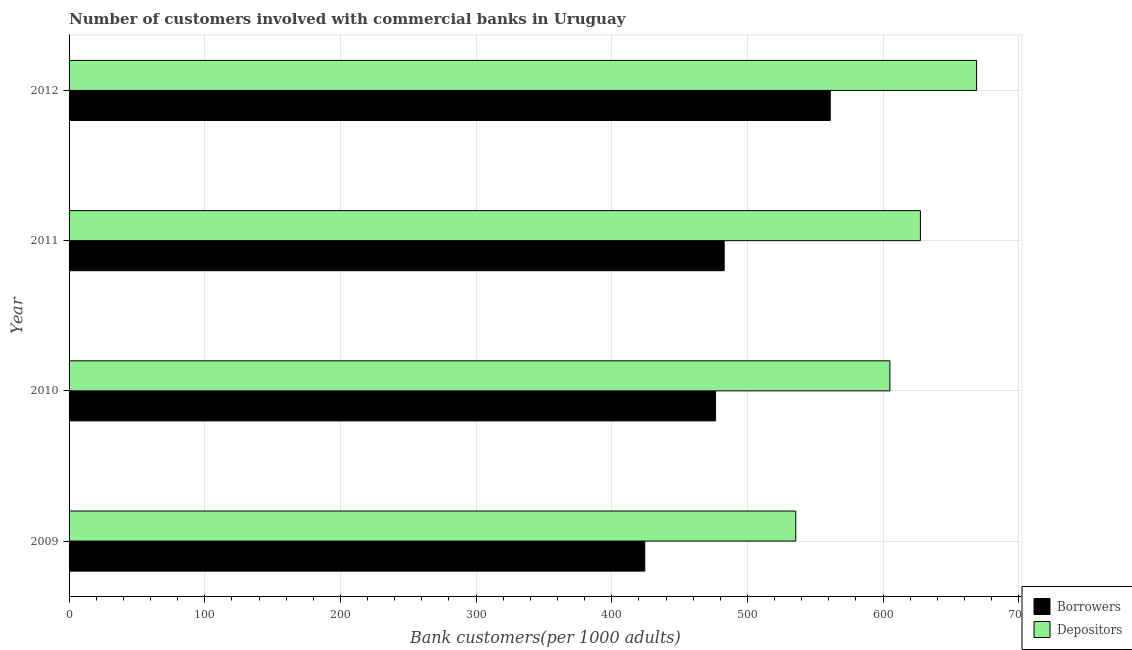How many different coloured bars are there?
Give a very brief answer. 2. Are the number of bars per tick equal to the number of legend labels?
Provide a short and direct response. Yes. What is the number of depositors in 2012?
Provide a succinct answer. 668.96. Across all years, what is the maximum number of borrowers?
Ensure brevity in your answer.  561.08. Across all years, what is the minimum number of depositors?
Offer a terse response. 535.65. What is the total number of depositors in the graph?
Make the answer very short. 2437.19. What is the difference between the number of depositors in 2009 and that in 2010?
Ensure brevity in your answer.  -69.39. What is the difference between the number of borrowers in 2010 and the number of depositors in 2011?
Make the answer very short. -150.98. What is the average number of depositors per year?
Give a very brief answer. 609.3. In the year 2011, what is the difference between the number of depositors and number of borrowers?
Offer a very short reply. 144.65. In how many years, is the number of borrowers greater than 220 ?
Provide a succinct answer. 4. What is the ratio of the number of borrowers in 2009 to that in 2011?
Your response must be concise. 0.88. Is the number of borrowers in 2011 less than that in 2012?
Give a very brief answer. Yes. What is the difference between the highest and the second highest number of depositors?
Offer a terse response. 41.43. What is the difference between the highest and the lowest number of depositors?
Your answer should be very brief. 133.31. In how many years, is the number of borrowers greater than the average number of borrowers taken over all years?
Your answer should be very brief. 1. Is the sum of the number of depositors in 2010 and 2012 greater than the maximum number of borrowers across all years?
Provide a short and direct response. Yes. What does the 2nd bar from the top in 2012 represents?
Make the answer very short. Borrowers. What does the 2nd bar from the bottom in 2012 represents?
Offer a very short reply. Depositors. How many bars are there?
Make the answer very short. 8. How many years are there in the graph?
Your response must be concise. 4. Are the values on the major ticks of X-axis written in scientific E-notation?
Your answer should be compact. No. Does the graph contain grids?
Your response must be concise. Yes. What is the title of the graph?
Ensure brevity in your answer.  Number of customers involved with commercial banks in Uruguay. What is the label or title of the X-axis?
Offer a very short reply. Bank customers(per 1000 adults). What is the label or title of the Y-axis?
Your answer should be compact. Year. What is the Bank customers(per 1000 adults) of Borrowers in 2009?
Provide a succinct answer. 424.36. What is the Bank customers(per 1000 adults) of Depositors in 2009?
Give a very brief answer. 535.65. What is the Bank customers(per 1000 adults) of Borrowers in 2010?
Provide a succinct answer. 476.55. What is the Bank customers(per 1000 adults) in Depositors in 2010?
Provide a short and direct response. 605.04. What is the Bank customers(per 1000 adults) of Borrowers in 2011?
Ensure brevity in your answer.  482.88. What is the Bank customers(per 1000 adults) in Depositors in 2011?
Ensure brevity in your answer.  627.53. What is the Bank customers(per 1000 adults) in Borrowers in 2012?
Offer a terse response. 561.08. What is the Bank customers(per 1000 adults) of Depositors in 2012?
Your answer should be compact. 668.96. Across all years, what is the maximum Bank customers(per 1000 adults) of Borrowers?
Offer a terse response. 561.08. Across all years, what is the maximum Bank customers(per 1000 adults) of Depositors?
Offer a very short reply. 668.96. Across all years, what is the minimum Bank customers(per 1000 adults) in Borrowers?
Offer a terse response. 424.36. Across all years, what is the minimum Bank customers(per 1000 adults) of Depositors?
Give a very brief answer. 535.65. What is the total Bank customers(per 1000 adults) of Borrowers in the graph?
Offer a very short reply. 1944.88. What is the total Bank customers(per 1000 adults) of Depositors in the graph?
Keep it short and to the point. 2437.19. What is the difference between the Bank customers(per 1000 adults) of Borrowers in 2009 and that in 2010?
Offer a very short reply. -52.19. What is the difference between the Bank customers(per 1000 adults) of Depositors in 2009 and that in 2010?
Give a very brief answer. -69.39. What is the difference between the Bank customers(per 1000 adults) in Borrowers in 2009 and that in 2011?
Your answer should be very brief. -58.52. What is the difference between the Bank customers(per 1000 adults) in Depositors in 2009 and that in 2011?
Your answer should be compact. -91.88. What is the difference between the Bank customers(per 1000 adults) of Borrowers in 2009 and that in 2012?
Provide a short and direct response. -136.71. What is the difference between the Bank customers(per 1000 adults) in Depositors in 2009 and that in 2012?
Your answer should be compact. -133.31. What is the difference between the Bank customers(per 1000 adults) in Borrowers in 2010 and that in 2011?
Provide a succinct answer. -6.33. What is the difference between the Bank customers(per 1000 adults) in Depositors in 2010 and that in 2011?
Provide a succinct answer. -22.49. What is the difference between the Bank customers(per 1000 adults) in Borrowers in 2010 and that in 2012?
Provide a short and direct response. -84.53. What is the difference between the Bank customers(per 1000 adults) of Depositors in 2010 and that in 2012?
Keep it short and to the point. -63.92. What is the difference between the Bank customers(per 1000 adults) of Borrowers in 2011 and that in 2012?
Your answer should be compact. -78.19. What is the difference between the Bank customers(per 1000 adults) in Depositors in 2011 and that in 2012?
Offer a very short reply. -41.43. What is the difference between the Bank customers(per 1000 adults) in Borrowers in 2009 and the Bank customers(per 1000 adults) in Depositors in 2010?
Offer a very short reply. -180.68. What is the difference between the Bank customers(per 1000 adults) of Borrowers in 2009 and the Bank customers(per 1000 adults) of Depositors in 2011?
Offer a terse response. -203.17. What is the difference between the Bank customers(per 1000 adults) in Borrowers in 2009 and the Bank customers(per 1000 adults) in Depositors in 2012?
Keep it short and to the point. -244.6. What is the difference between the Bank customers(per 1000 adults) of Borrowers in 2010 and the Bank customers(per 1000 adults) of Depositors in 2011?
Provide a succinct answer. -150.98. What is the difference between the Bank customers(per 1000 adults) in Borrowers in 2010 and the Bank customers(per 1000 adults) in Depositors in 2012?
Offer a terse response. -192.41. What is the difference between the Bank customers(per 1000 adults) of Borrowers in 2011 and the Bank customers(per 1000 adults) of Depositors in 2012?
Offer a very short reply. -186.08. What is the average Bank customers(per 1000 adults) of Borrowers per year?
Make the answer very short. 486.22. What is the average Bank customers(per 1000 adults) in Depositors per year?
Ensure brevity in your answer.  609.3. In the year 2009, what is the difference between the Bank customers(per 1000 adults) of Borrowers and Bank customers(per 1000 adults) of Depositors?
Give a very brief answer. -111.29. In the year 2010, what is the difference between the Bank customers(per 1000 adults) of Borrowers and Bank customers(per 1000 adults) of Depositors?
Provide a succinct answer. -128.49. In the year 2011, what is the difference between the Bank customers(per 1000 adults) of Borrowers and Bank customers(per 1000 adults) of Depositors?
Give a very brief answer. -144.65. In the year 2012, what is the difference between the Bank customers(per 1000 adults) of Borrowers and Bank customers(per 1000 adults) of Depositors?
Offer a terse response. -107.88. What is the ratio of the Bank customers(per 1000 adults) in Borrowers in 2009 to that in 2010?
Offer a very short reply. 0.89. What is the ratio of the Bank customers(per 1000 adults) in Depositors in 2009 to that in 2010?
Give a very brief answer. 0.89. What is the ratio of the Bank customers(per 1000 adults) in Borrowers in 2009 to that in 2011?
Provide a succinct answer. 0.88. What is the ratio of the Bank customers(per 1000 adults) in Depositors in 2009 to that in 2011?
Your answer should be compact. 0.85. What is the ratio of the Bank customers(per 1000 adults) in Borrowers in 2009 to that in 2012?
Keep it short and to the point. 0.76. What is the ratio of the Bank customers(per 1000 adults) in Depositors in 2009 to that in 2012?
Offer a very short reply. 0.8. What is the ratio of the Bank customers(per 1000 adults) in Borrowers in 2010 to that in 2011?
Offer a terse response. 0.99. What is the ratio of the Bank customers(per 1000 adults) in Depositors in 2010 to that in 2011?
Provide a succinct answer. 0.96. What is the ratio of the Bank customers(per 1000 adults) in Borrowers in 2010 to that in 2012?
Keep it short and to the point. 0.85. What is the ratio of the Bank customers(per 1000 adults) in Depositors in 2010 to that in 2012?
Your response must be concise. 0.9. What is the ratio of the Bank customers(per 1000 adults) in Borrowers in 2011 to that in 2012?
Offer a terse response. 0.86. What is the ratio of the Bank customers(per 1000 adults) of Depositors in 2011 to that in 2012?
Provide a short and direct response. 0.94. What is the difference between the highest and the second highest Bank customers(per 1000 adults) of Borrowers?
Ensure brevity in your answer.  78.19. What is the difference between the highest and the second highest Bank customers(per 1000 adults) in Depositors?
Your response must be concise. 41.43. What is the difference between the highest and the lowest Bank customers(per 1000 adults) in Borrowers?
Offer a very short reply. 136.71. What is the difference between the highest and the lowest Bank customers(per 1000 adults) of Depositors?
Offer a terse response. 133.31. 